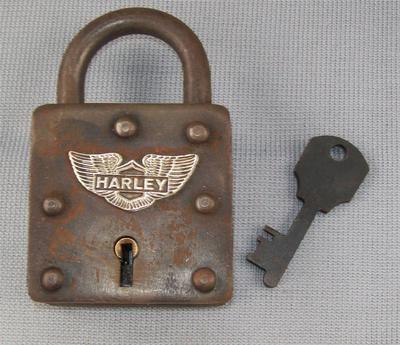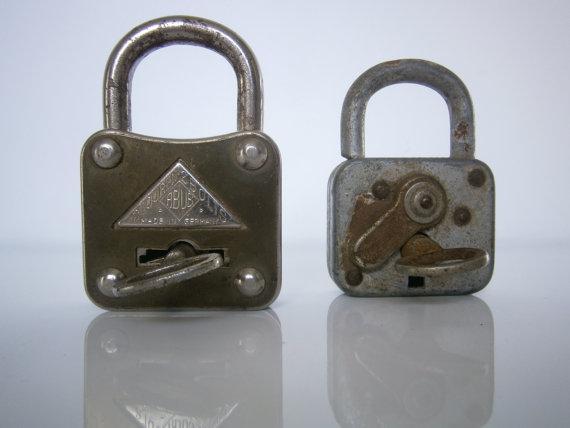The first image is the image on the left, the second image is the image on the right. Considering the images on both sides, is "There are three padlocks in total." valid? Answer yes or no. Yes. The first image is the image on the left, the second image is the image on the right. Analyze the images presented: Is the assertion "One image shows three antique padlocks with keyholes visible on the lower front panel of the padlock, with keys displayed in front of them." valid? Answer yes or no. No. 